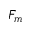<formula> <loc_0><loc_0><loc_500><loc_500>F _ { m }</formula> 